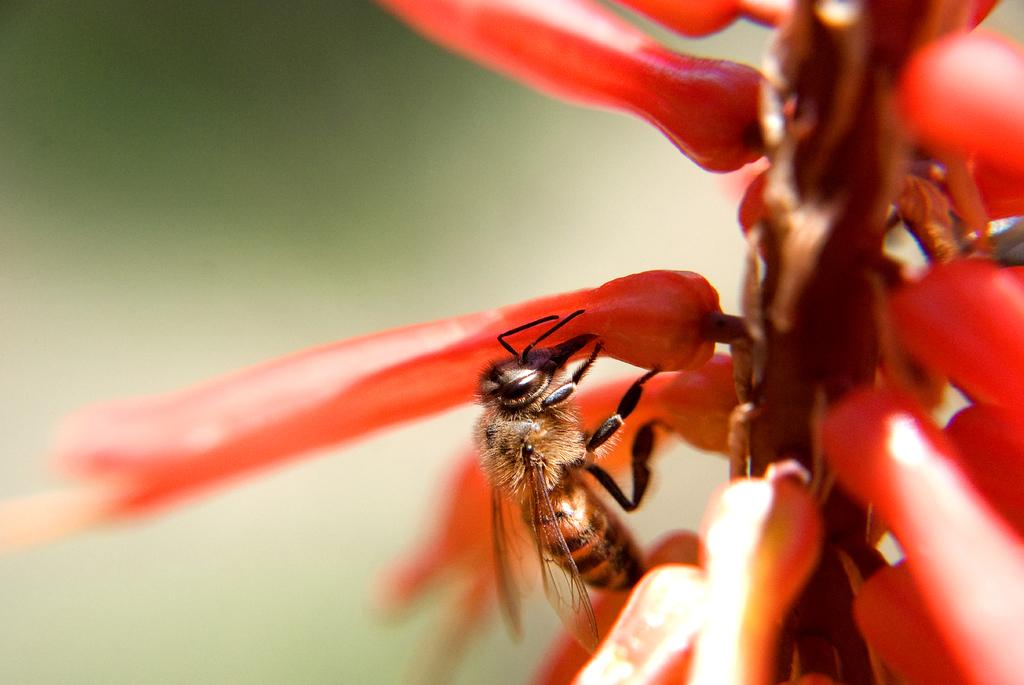What is the main subject of the image? The main subject of the image is a bunch of flowers. What can be said about the color of the flowers? The flowers are red in color. Are there any other living creatures present in the image? Yes, a honey bee is sitting on one of the flowers. How many legs can be seen on the screw in the image? There is no screw present in the image, so it is not possible to determine the number of legs on a screw. 